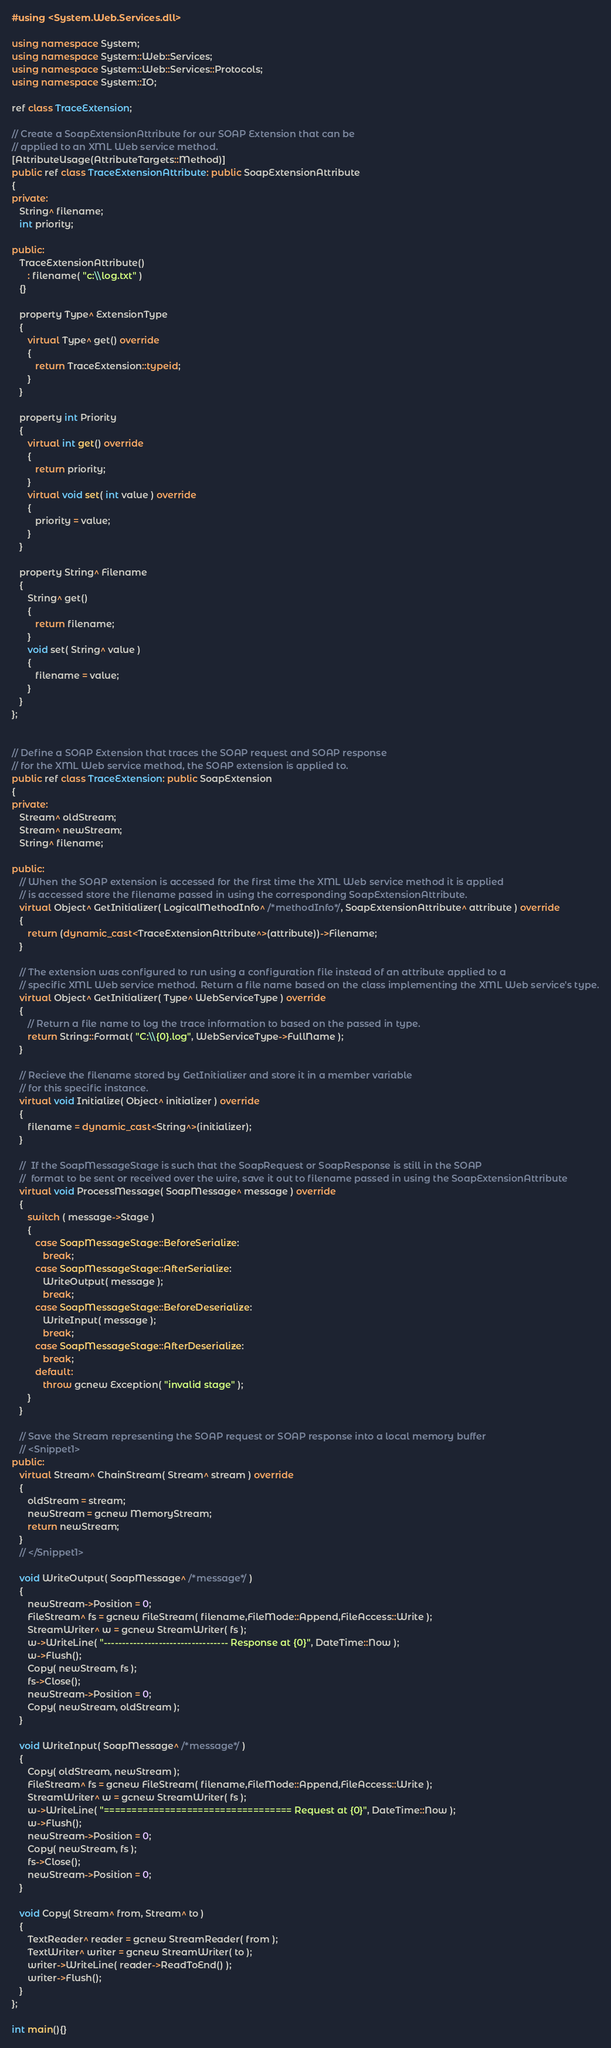<code> <loc_0><loc_0><loc_500><loc_500><_C++_>#using <System.Web.Services.dll>

using namespace System;
using namespace System::Web::Services;
using namespace System::Web::Services::Protocols;
using namespace System::IO;

ref class TraceExtension;

// Create a SoapExtensionAttribute for our SOAP Extension that can be
// applied to an XML Web service method.
[AttributeUsage(AttributeTargets::Method)]
public ref class TraceExtensionAttribute: public SoapExtensionAttribute
{
private:
   String^ filename;
   int priority;

public:
   TraceExtensionAttribute()
      : filename( "c:\\log.txt" )
   {}

   property Type^ ExtensionType 
   {
      virtual Type^ get() override
      {
         return TraceExtension::typeid;
      }
   }

   property int Priority 
   {
      virtual int get() override
      {
         return priority;
      }
      virtual void set( int value ) override
      {
         priority = value;
      }
   }

   property String^ Filename 
   {
      String^ get()
      {
         return filename;
      }
      void set( String^ value )
      {
         filename = value;
      }
   }
};


// Define a SOAP Extension that traces the SOAP request and SOAP response
// for the XML Web service method, the SOAP extension is applied to.
public ref class TraceExtension: public SoapExtension
{
private:
   Stream^ oldStream;
   Stream^ newStream;
   String^ filename;

public:
   // When the SOAP extension is accessed for the first time the XML Web service method it is applied
   // is accessed store the filename passed in using the corresponding SoapExtensionAttribute.    
   virtual Object^ GetInitializer( LogicalMethodInfo^ /*methodInfo*/, SoapExtensionAttribute^ attribute ) override
   {
      return (dynamic_cast<TraceExtensionAttribute^>(attribute))->Filename;
   }

   // The extension was configured to run using a configuration file instead of an attribute applied to a 
   // specific XML Web service method. Return a file name based on the class implementing the XML Web service's type.
   virtual Object^ GetInitializer( Type^ WebServiceType ) override
   {
      // Return a file name to log the trace information to based on the passed in type.
      return String::Format( "C:\\{0}.log", WebServiceType->FullName );
   }

   // Recieve the filename stored by GetInitializer and store it in a member variable
   // for this specific instance.
   virtual void Initialize( Object^ initializer ) override
   {
      filename = dynamic_cast<String^>(initializer);
   }

   //  If the SoapMessageStage is such that the SoapRequest or SoapResponse is still in the SOAP 
   //  format to be sent or received over the wire, save it out to filename passed in using the SoapExtensionAttribute
   virtual void ProcessMessage( SoapMessage^ message ) override
   {
      switch ( message->Stage )
      {
         case SoapMessageStage::BeforeSerialize:
            break;
         case SoapMessageStage::AfterSerialize:
            WriteOutput( message );
            break;
         case SoapMessageStage::BeforeDeserialize:
            WriteInput( message );
            break;
         case SoapMessageStage::AfterDeserialize:
            break;
         default:
            throw gcnew Exception( "invalid stage" );
      }
   }

   // Save the Stream representing the SOAP request or SOAP response into a local memory buffer
   // <Snippet1>
public:
   virtual Stream^ ChainStream( Stream^ stream ) override
   {
      oldStream = stream;
      newStream = gcnew MemoryStream;
      return newStream;
   }
   // </Snippet1>

   void WriteOutput( SoapMessage^ /*message*/ )
   {
      newStream->Position = 0;
      FileStream^ fs = gcnew FileStream( filename,FileMode::Append,FileAccess::Write );
      StreamWriter^ w = gcnew StreamWriter( fs );
      w->WriteLine( "---------------------------------- Response at {0}", DateTime::Now );
      w->Flush();
      Copy( newStream, fs );
      fs->Close();
      newStream->Position = 0;
      Copy( newStream, oldStream );
   }

   void WriteInput( SoapMessage^ /*message*/ )
   {
      Copy( oldStream, newStream );
      FileStream^ fs = gcnew FileStream( filename,FileMode::Append,FileAccess::Write );
      StreamWriter^ w = gcnew StreamWriter( fs );
      w->WriteLine( "================================== Request at {0}", DateTime::Now );
      w->Flush();
      newStream->Position = 0;
      Copy( newStream, fs );
      fs->Close();
      newStream->Position = 0;
   }

   void Copy( Stream^ from, Stream^ to )
   {
      TextReader^ reader = gcnew StreamReader( from );
      TextWriter^ writer = gcnew StreamWriter( to );
      writer->WriteLine( reader->ReadToEnd() );
      writer->Flush();
   }
};

int main(){}
</code> 